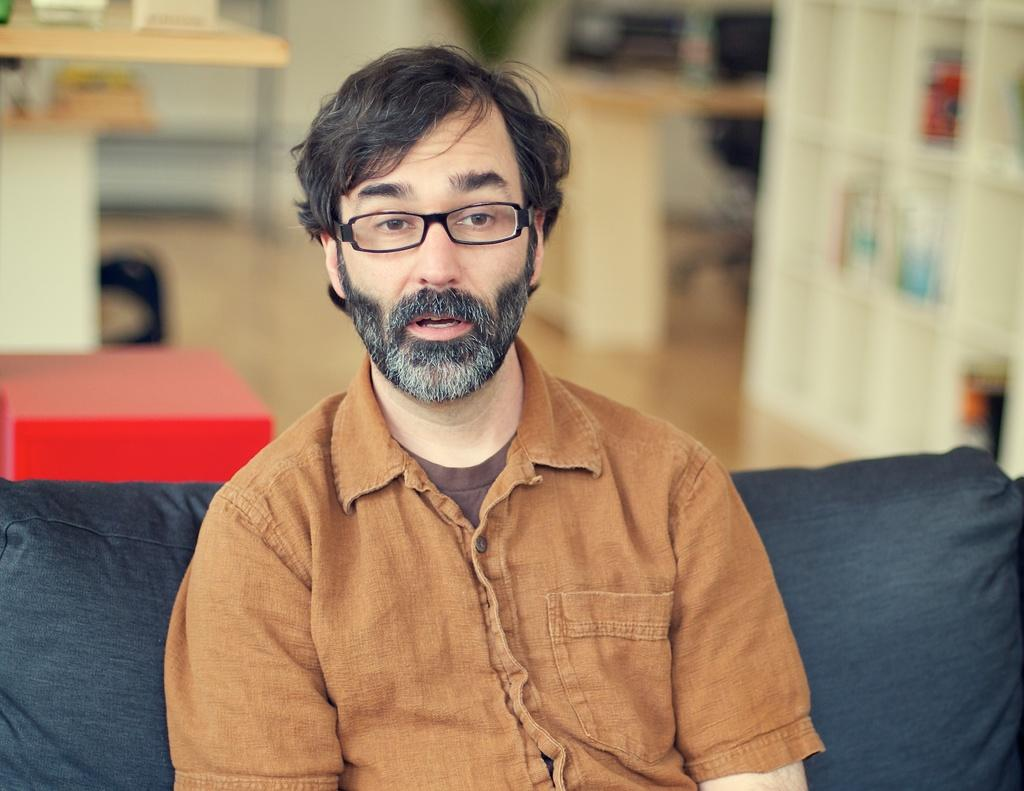What is the man in the image doing? The man is seated on the sofa in the image. What can be seen on the man's face in the image? The man is wearing spectacles in the image. What color is the shirt the man is wearing? The man is wearing a brown color shirt in the image. What furniture is visible in the image besides the sofa? There is a table and a cupboard visible in the image. What type of company is depicted in the picture on the wall in the image? There is no picture on the wall in the image, so it is not possible to determine what type of company might be depicted. 